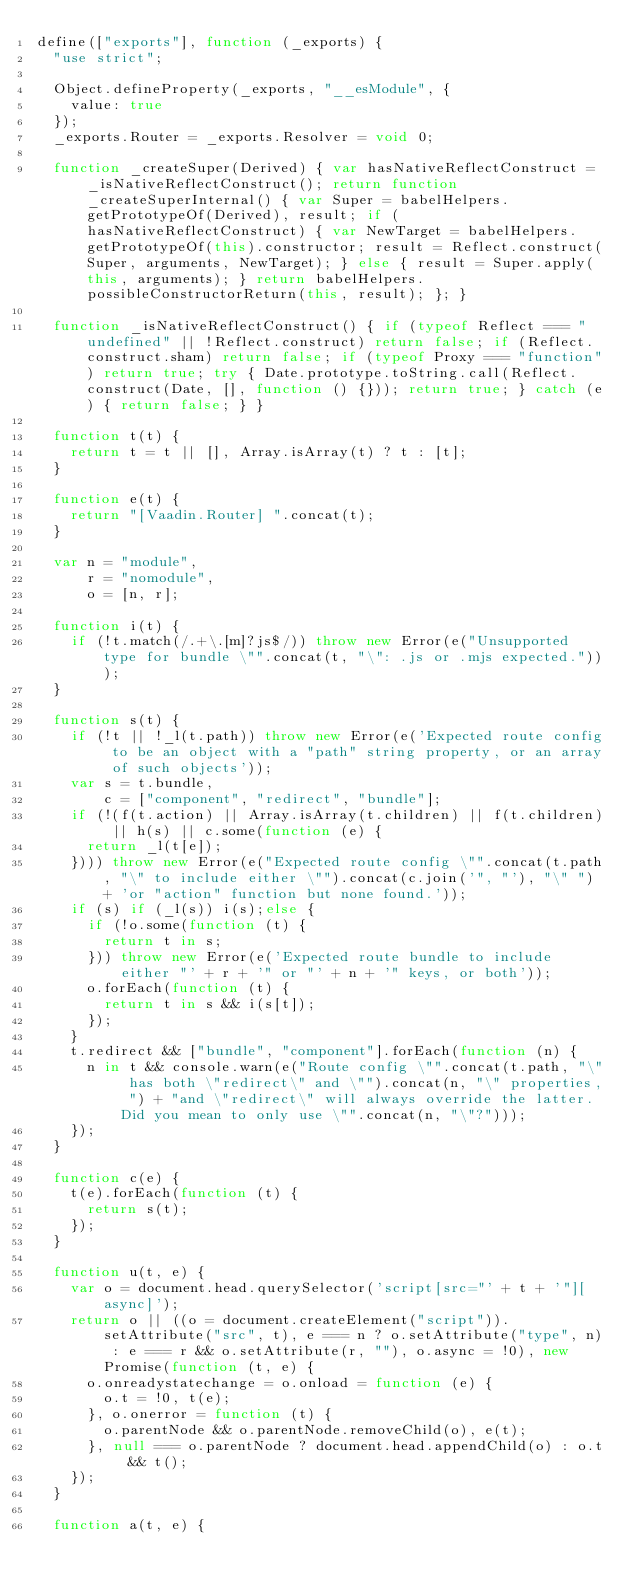<code> <loc_0><loc_0><loc_500><loc_500><_JavaScript_>define(["exports"], function (_exports) {
  "use strict";

  Object.defineProperty(_exports, "__esModule", {
    value: true
  });
  _exports.Router = _exports.Resolver = void 0;

  function _createSuper(Derived) { var hasNativeReflectConstruct = _isNativeReflectConstruct(); return function _createSuperInternal() { var Super = babelHelpers.getPrototypeOf(Derived), result; if (hasNativeReflectConstruct) { var NewTarget = babelHelpers.getPrototypeOf(this).constructor; result = Reflect.construct(Super, arguments, NewTarget); } else { result = Super.apply(this, arguments); } return babelHelpers.possibleConstructorReturn(this, result); }; }

  function _isNativeReflectConstruct() { if (typeof Reflect === "undefined" || !Reflect.construct) return false; if (Reflect.construct.sham) return false; if (typeof Proxy === "function") return true; try { Date.prototype.toString.call(Reflect.construct(Date, [], function () {})); return true; } catch (e) { return false; } }

  function t(t) {
    return t = t || [], Array.isArray(t) ? t : [t];
  }

  function e(t) {
    return "[Vaadin.Router] ".concat(t);
  }

  var n = "module",
      r = "nomodule",
      o = [n, r];

  function i(t) {
    if (!t.match(/.+\.[m]?js$/)) throw new Error(e("Unsupported type for bundle \"".concat(t, "\": .js or .mjs expected.")));
  }

  function s(t) {
    if (!t || !_l(t.path)) throw new Error(e('Expected route config to be an object with a "path" string property, or an array of such objects'));
    var s = t.bundle,
        c = ["component", "redirect", "bundle"];
    if (!(f(t.action) || Array.isArray(t.children) || f(t.children) || h(s) || c.some(function (e) {
      return _l(t[e]);
    }))) throw new Error(e("Expected route config \"".concat(t.path, "\" to include either \"").concat(c.join('", "'), "\" ") + 'or "action" function but none found.'));
    if (s) if (_l(s)) i(s);else {
      if (!o.some(function (t) {
        return t in s;
      })) throw new Error(e('Expected route bundle to include either "' + r + '" or "' + n + '" keys, or both'));
      o.forEach(function (t) {
        return t in s && i(s[t]);
      });
    }
    t.redirect && ["bundle", "component"].forEach(function (n) {
      n in t && console.warn(e("Route config \"".concat(t.path, "\" has both \"redirect\" and \"").concat(n, "\" properties, ") + "and \"redirect\" will always override the latter. Did you mean to only use \"".concat(n, "\"?")));
    });
  }

  function c(e) {
    t(e).forEach(function (t) {
      return s(t);
    });
  }

  function u(t, e) {
    var o = document.head.querySelector('script[src="' + t + '"][async]');
    return o || ((o = document.createElement("script")).setAttribute("src", t), e === n ? o.setAttribute("type", n) : e === r && o.setAttribute(r, ""), o.async = !0), new Promise(function (t, e) {
      o.onreadystatechange = o.onload = function (e) {
        o.t = !0, t(e);
      }, o.onerror = function (t) {
        o.parentNode && o.parentNode.removeChild(o), e(t);
      }, null === o.parentNode ? document.head.appendChild(o) : o.t && t();
    });
  }

  function a(t, e) {</code> 